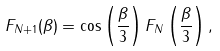<formula> <loc_0><loc_0><loc_500><loc_500>F _ { N + 1 } ( \beta ) = \cos \left ( \frac { \beta } { 3 } \right ) F _ { N } \left ( \frac { \beta } { 3 } \right ) ,</formula> 